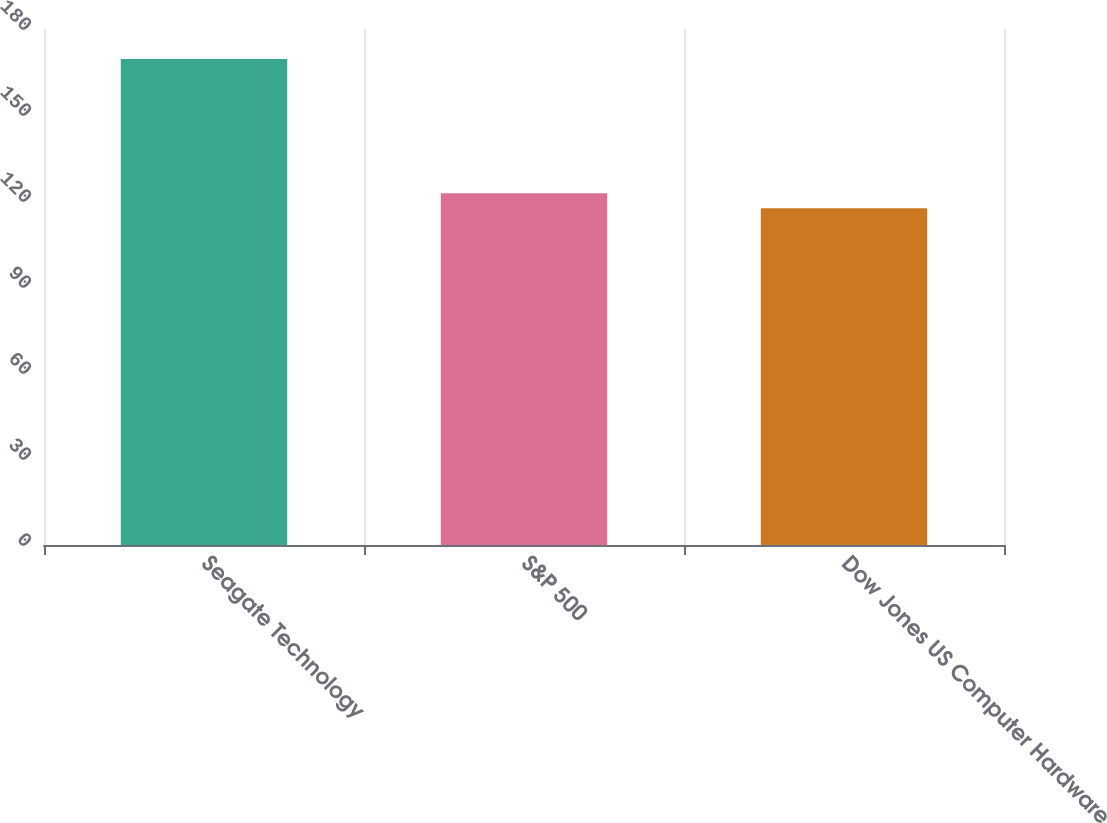<chart> <loc_0><loc_0><loc_500><loc_500><bar_chart><fcel>Seagate Technology<fcel>S&P 500<fcel>Dow Jones US Computer Hardware<nl><fcel>169.53<fcel>122.7<fcel>117.5<nl></chart> 